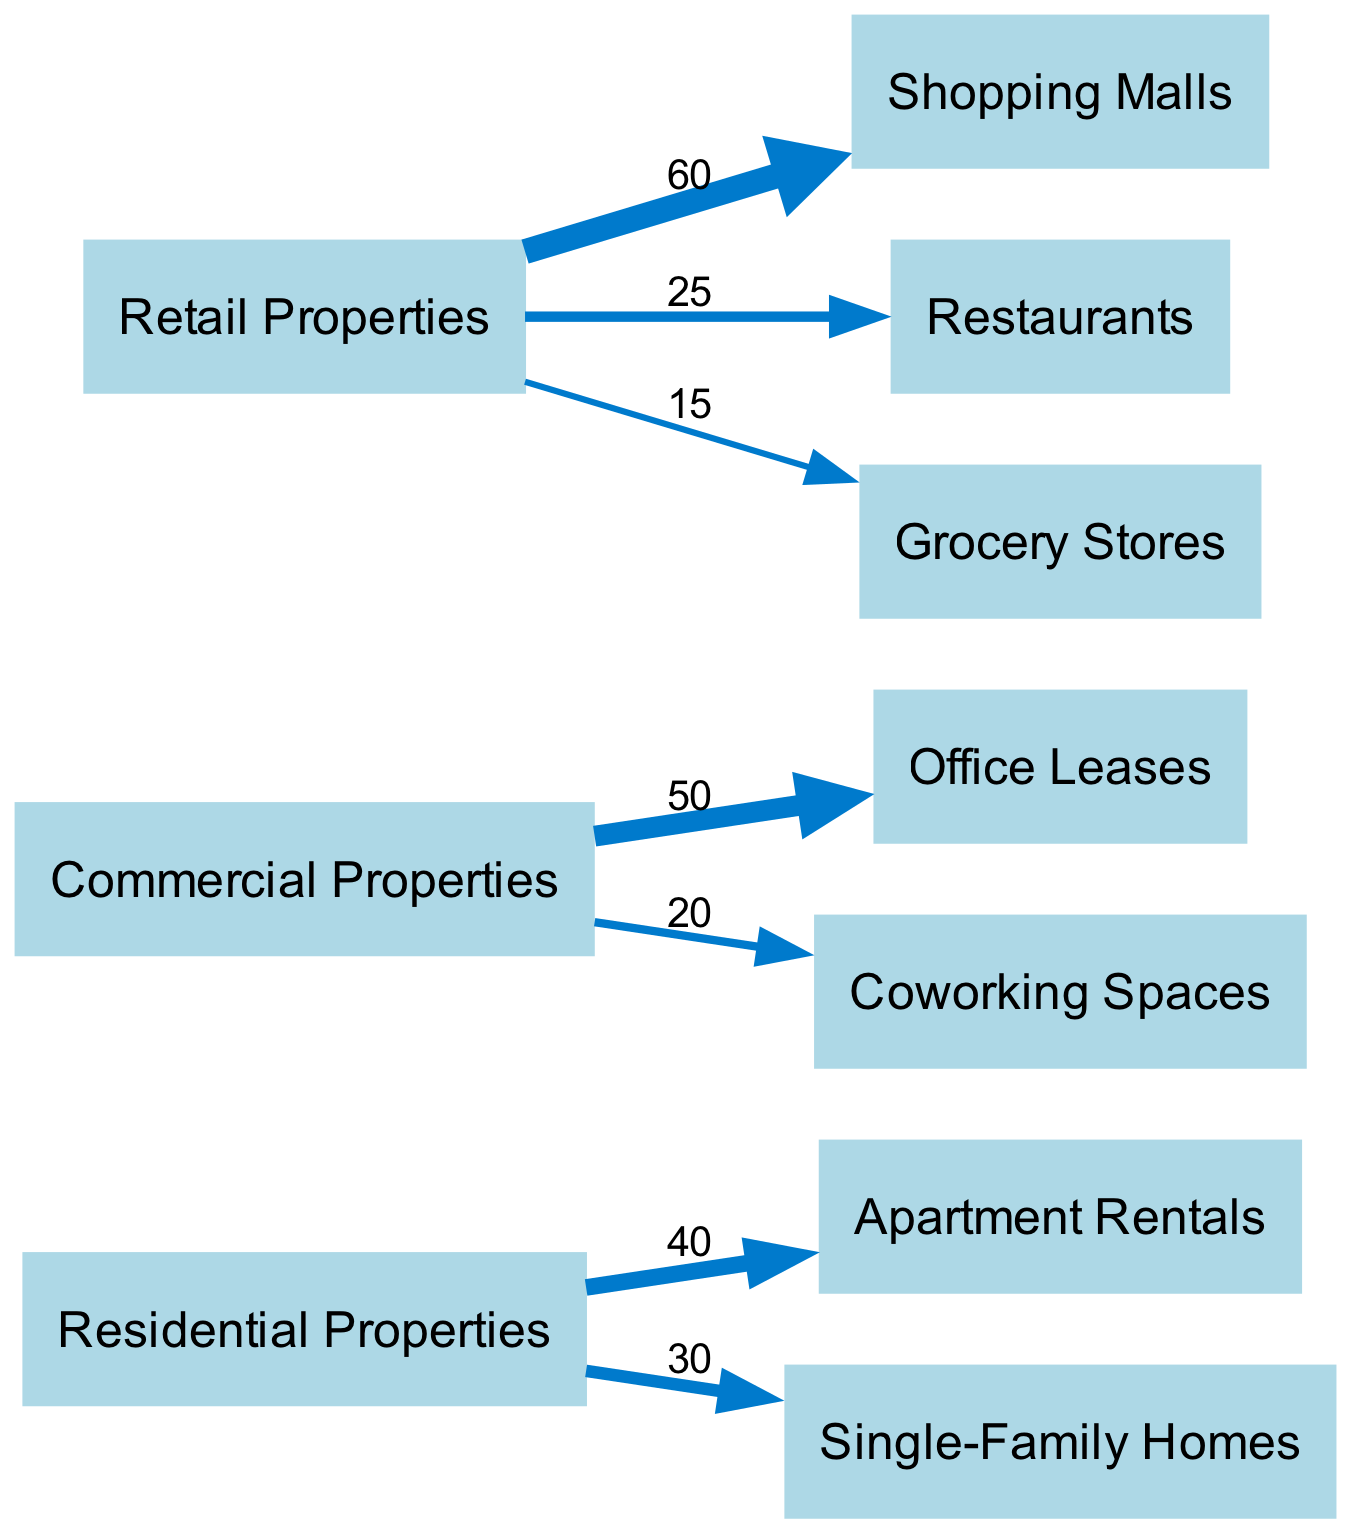What is the total revenue from Residential Properties? To find the total revenue from Residential Properties, we sum the values of the outgoing links from "Residential Properties." The values are 40 (Apartment Rentals) and 30 (Single-Family Homes), so 40 + 30 = 70.
Answer: 70 Which tenant category has the highest revenue from Retail Properties? Looking at the links from "Retail Properties," we see three categories: Shopping Malls with a revenue of 60, Restaurants with 25, and Grocery Stores with 15. The highest value is 60, corresponding to Shopping Malls.
Answer: Shopping Malls How many total nodes are there in the diagram? The nodes are "Residential Properties," "Commercial Properties," "Retail Properties," "Apartment Rentals," "Office Leases," "Shopping Malls," "Single-Family Homes," "Coworking Spaces," "Restaurants," and "Grocery Stores." Counting them gives us a total of 10 nodes.
Answer: 10 What is the revenue from Commercial Properties to Coworking Spaces? The link from "Commercial Properties" to "Coworking Spaces" shows a value of 20. Therefore, the revenue from Commercial Properties to Coworking Spaces is directly indicated as 20.
Answer: 20 Which category generates more revenue: Office Leases or Coworking Spaces? By examining the links, we see that Office Leases generate 50 while Coworking Spaces generate 20. Thus, Office Leases generate more revenue than Coworking Spaces since 50 is greater than 20.
Answer: Office Leases What is the total revenue generated by Retail Properties? To find the total revenue from Retail Properties, we add the revenue from the outgoing links: Shopping Malls (60), Restaurants (25), and Grocery Stores (15). This sums to 60 + 25 + 15 = 100.
Answer: 100 Which property type has the highest overall revenue? Looking at the total revenues, Residential Properties total to 70, Commercial Properties to 70 (50 + 20), and Retail Properties to 100. Comparing these totals, Retail Properties have the highest overall revenue at 100.
Answer: Retail Properties How much more revenue does Shopping Malls generate compared to Grocery Stores? From the links, Shopping Malls generate 60, while Grocery Stores generate 15. To find the difference, we calculate 60 - 15 = 45, indicating that Shopping Malls generate 45 more than Grocery Stores.
Answer: 45 